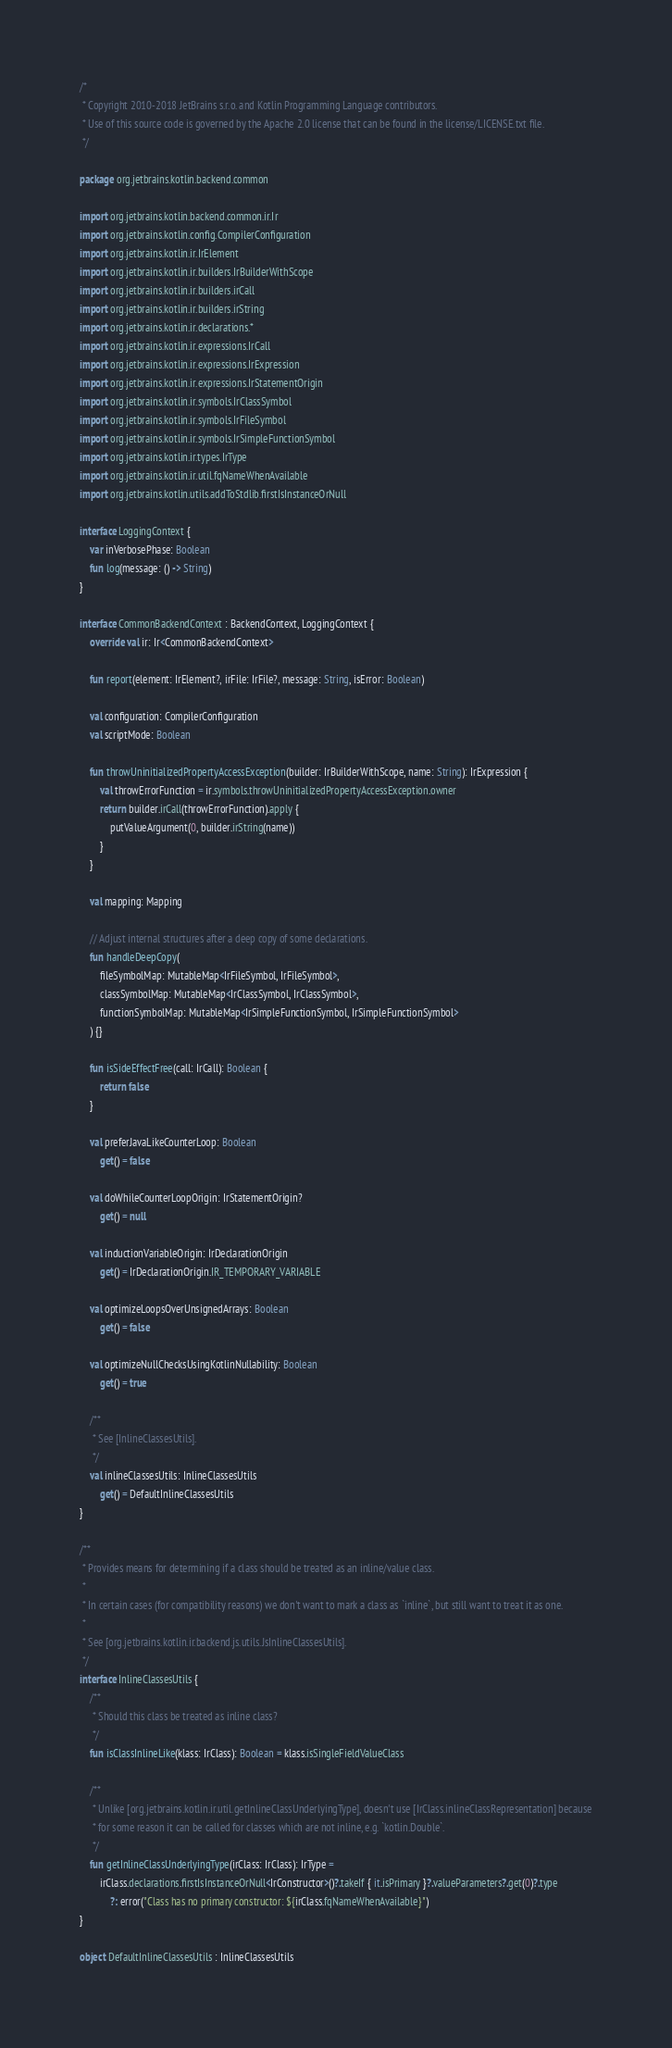Convert code to text. <code><loc_0><loc_0><loc_500><loc_500><_Kotlin_>/*
 * Copyright 2010-2018 JetBrains s.r.o. and Kotlin Programming Language contributors.
 * Use of this source code is governed by the Apache 2.0 license that can be found in the license/LICENSE.txt file.
 */

package org.jetbrains.kotlin.backend.common

import org.jetbrains.kotlin.backend.common.ir.Ir
import org.jetbrains.kotlin.config.CompilerConfiguration
import org.jetbrains.kotlin.ir.IrElement
import org.jetbrains.kotlin.ir.builders.IrBuilderWithScope
import org.jetbrains.kotlin.ir.builders.irCall
import org.jetbrains.kotlin.ir.builders.irString
import org.jetbrains.kotlin.ir.declarations.*
import org.jetbrains.kotlin.ir.expressions.IrCall
import org.jetbrains.kotlin.ir.expressions.IrExpression
import org.jetbrains.kotlin.ir.expressions.IrStatementOrigin
import org.jetbrains.kotlin.ir.symbols.IrClassSymbol
import org.jetbrains.kotlin.ir.symbols.IrFileSymbol
import org.jetbrains.kotlin.ir.symbols.IrSimpleFunctionSymbol
import org.jetbrains.kotlin.ir.types.IrType
import org.jetbrains.kotlin.ir.util.fqNameWhenAvailable
import org.jetbrains.kotlin.utils.addToStdlib.firstIsInstanceOrNull

interface LoggingContext {
    var inVerbosePhase: Boolean
    fun log(message: () -> String)
}

interface CommonBackendContext : BackendContext, LoggingContext {
    override val ir: Ir<CommonBackendContext>

    fun report(element: IrElement?, irFile: IrFile?, message: String, isError: Boolean)

    val configuration: CompilerConfiguration
    val scriptMode: Boolean

    fun throwUninitializedPropertyAccessException(builder: IrBuilderWithScope, name: String): IrExpression {
        val throwErrorFunction = ir.symbols.throwUninitializedPropertyAccessException.owner
        return builder.irCall(throwErrorFunction).apply {
            putValueArgument(0, builder.irString(name))
        }
    }

    val mapping: Mapping

    // Adjust internal structures after a deep copy of some declarations.
    fun handleDeepCopy(
        fileSymbolMap: MutableMap<IrFileSymbol, IrFileSymbol>,
        classSymbolMap: MutableMap<IrClassSymbol, IrClassSymbol>,
        functionSymbolMap: MutableMap<IrSimpleFunctionSymbol, IrSimpleFunctionSymbol>
    ) {}

    fun isSideEffectFree(call: IrCall): Boolean {
        return false
    }

    val preferJavaLikeCounterLoop: Boolean
        get() = false

    val doWhileCounterLoopOrigin: IrStatementOrigin?
        get() = null

    val inductionVariableOrigin: IrDeclarationOrigin
        get() = IrDeclarationOrigin.IR_TEMPORARY_VARIABLE

    val optimizeLoopsOverUnsignedArrays: Boolean
        get() = false

    val optimizeNullChecksUsingKotlinNullability: Boolean
        get() = true

    /**
     * See [InlineClassesUtils].
     */
    val inlineClassesUtils: InlineClassesUtils
        get() = DefaultInlineClassesUtils
}

/**
 * Provides means for determining if a class should be treated as an inline/value class.
 *
 * In certain cases (for compatibility reasons) we don't want to mark a class as `inline`, but still want to treat it as one.
 *
 * See [org.jetbrains.kotlin.ir.backend.js.utils.JsInlineClassesUtils].
 */
interface InlineClassesUtils {
    /**
     * Should this class be treated as inline class?
     */
    fun isClassInlineLike(klass: IrClass): Boolean = klass.isSingleFieldValueClass

    /**
     * Unlike [org.jetbrains.kotlin.ir.util.getInlineClassUnderlyingType], doesn't use [IrClass.inlineClassRepresentation] because
     * for some reason it can be called for classes which are not inline, e.g. `kotlin.Double`.
     */
    fun getInlineClassUnderlyingType(irClass: IrClass): IrType =
        irClass.declarations.firstIsInstanceOrNull<IrConstructor>()?.takeIf { it.isPrimary }?.valueParameters?.get(0)?.type
            ?: error("Class has no primary constructor: ${irClass.fqNameWhenAvailable}")
}

object DefaultInlineClassesUtils : InlineClassesUtils
</code> 